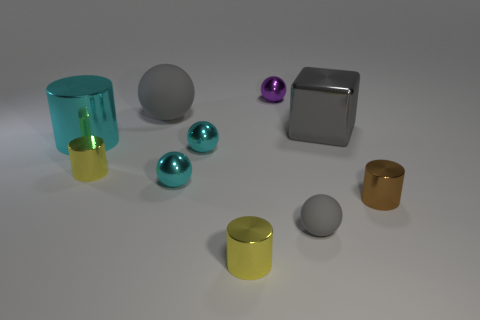How many other things are there of the same color as the large cube?
Give a very brief answer. 2. Is there anything else that has the same shape as the large gray rubber object?
Your answer should be very brief. Yes. There is a large ball that is the same color as the small matte ball; what material is it?
Give a very brief answer. Rubber. How many brown cylinders are on the left side of the small thing that is in front of the gray sphere that is in front of the large cyan metallic object?
Make the answer very short. 0. How many tiny rubber spheres are to the left of the tiny purple metal thing?
Offer a very short reply. 0. How many cyan cylinders have the same material as the small purple sphere?
Your answer should be compact. 1. What color is the large cylinder that is the same material as the gray cube?
Offer a very short reply. Cyan. What material is the gray ball on the right side of the yellow cylinder that is in front of the tiny cylinder that is right of the purple sphere?
Your response must be concise. Rubber. Does the sphere that is in front of the brown thing have the same size as the block?
Make the answer very short. No. How many tiny objects are yellow metallic cylinders or red objects?
Ensure brevity in your answer.  2. 